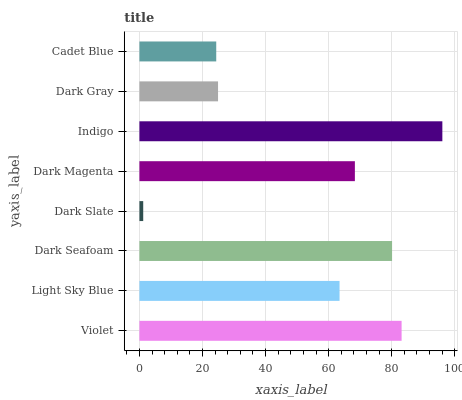Is Dark Slate the minimum?
Answer yes or no. Yes. Is Indigo the maximum?
Answer yes or no. Yes. Is Light Sky Blue the minimum?
Answer yes or no. No. Is Light Sky Blue the maximum?
Answer yes or no. No. Is Violet greater than Light Sky Blue?
Answer yes or no. Yes. Is Light Sky Blue less than Violet?
Answer yes or no. Yes. Is Light Sky Blue greater than Violet?
Answer yes or no. No. Is Violet less than Light Sky Blue?
Answer yes or no. No. Is Dark Magenta the high median?
Answer yes or no. Yes. Is Light Sky Blue the low median?
Answer yes or no. Yes. Is Indigo the high median?
Answer yes or no. No. Is Indigo the low median?
Answer yes or no. No. 